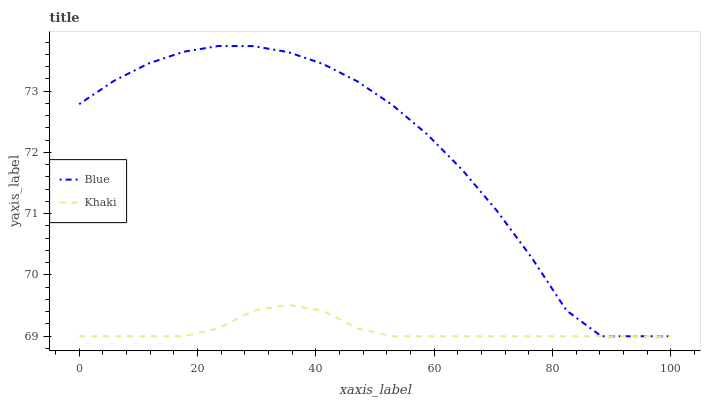Does Khaki have the minimum area under the curve?
Answer yes or no. Yes. Does Blue have the maximum area under the curve?
Answer yes or no. Yes. Does Khaki have the maximum area under the curve?
Answer yes or no. No. Is Khaki the smoothest?
Answer yes or no. Yes. Is Blue the roughest?
Answer yes or no. Yes. Is Khaki the roughest?
Answer yes or no. No. Does Blue have the lowest value?
Answer yes or no. Yes. Does Blue have the highest value?
Answer yes or no. Yes. Does Khaki have the highest value?
Answer yes or no. No. Does Khaki intersect Blue?
Answer yes or no. Yes. Is Khaki less than Blue?
Answer yes or no. No. Is Khaki greater than Blue?
Answer yes or no. No. 